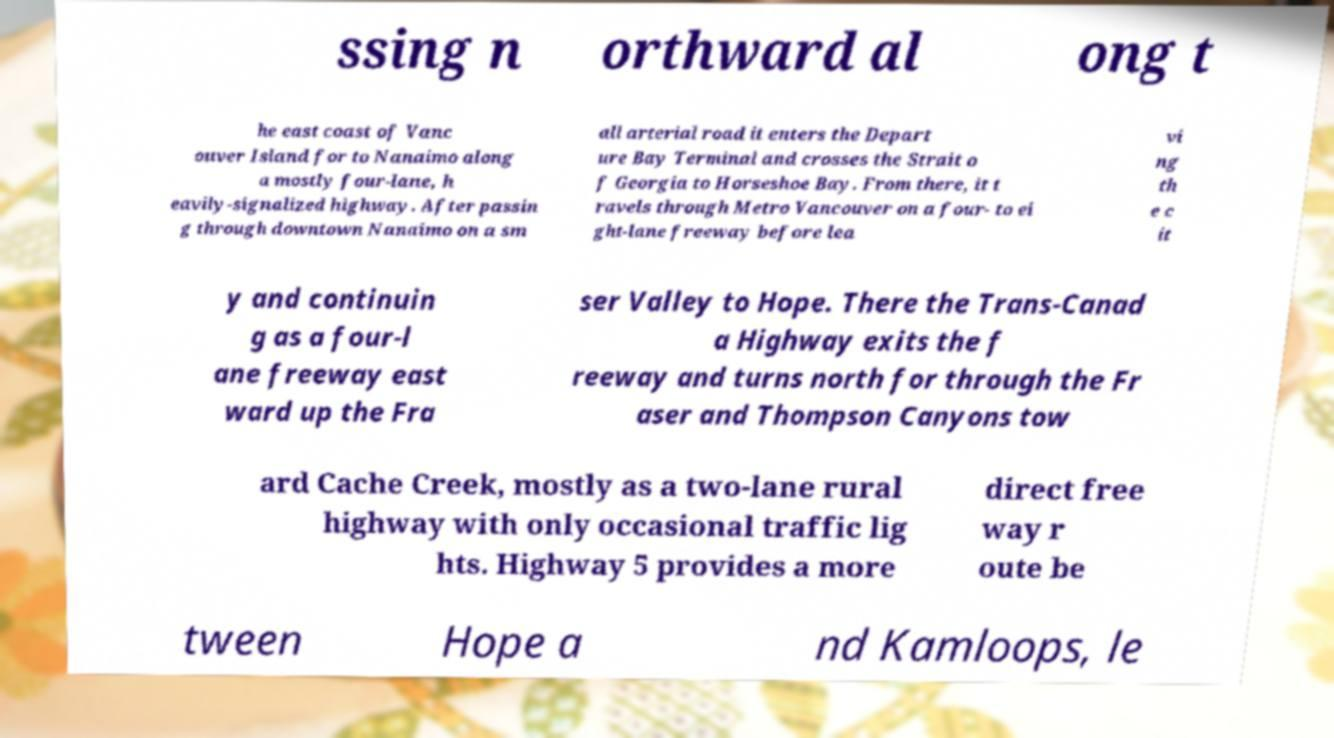Please read and relay the text visible in this image. What does it say? ssing n orthward al ong t he east coast of Vanc ouver Island for to Nanaimo along a mostly four-lane, h eavily-signalized highway. After passin g through downtown Nanaimo on a sm all arterial road it enters the Depart ure Bay Terminal and crosses the Strait o f Georgia to Horseshoe Bay. From there, it t ravels through Metro Vancouver on a four- to ei ght-lane freeway before lea vi ng th e c it y and continuin g as a four-l ane freeway east ward up the Fra ser Valley to Hope. There the Trans-Canad a Highway exits the f reeway and turns north for through the Fr aser and Thompson Canyons tow ard Cache Creek, mostly as a two-lane rural highway with only occasional traffic lig hts. Highway 5 provides a more direct free way r oute be tween Hope a nd Kamloops, le 